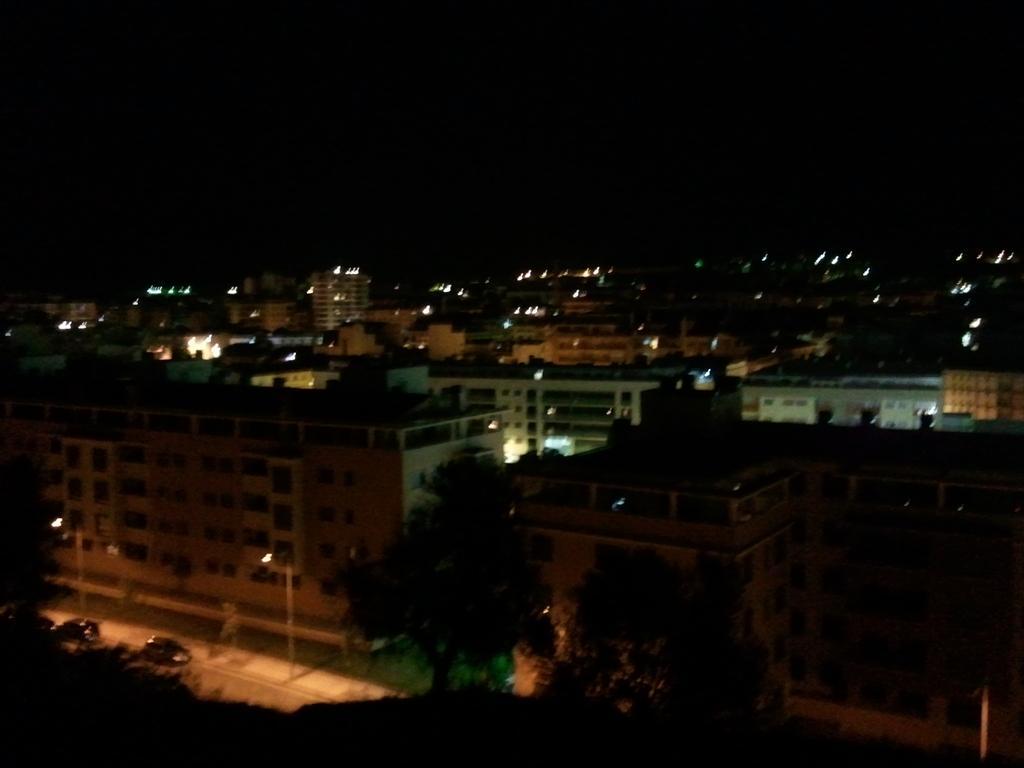Can you describe this image briefly? In this image, I can see the view of a city with the buildings and lights. These are the trees. I can see two cars on the road. The background looks dark. 